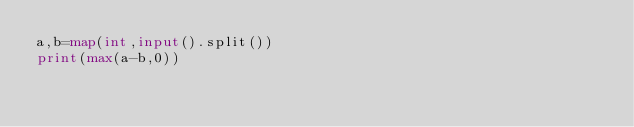Convert code to text. <code><loc_0><loc_0><loc_500><loc_500><_Python_>a,b=map(int,input().split())
print(max(a-b,0))</code> 